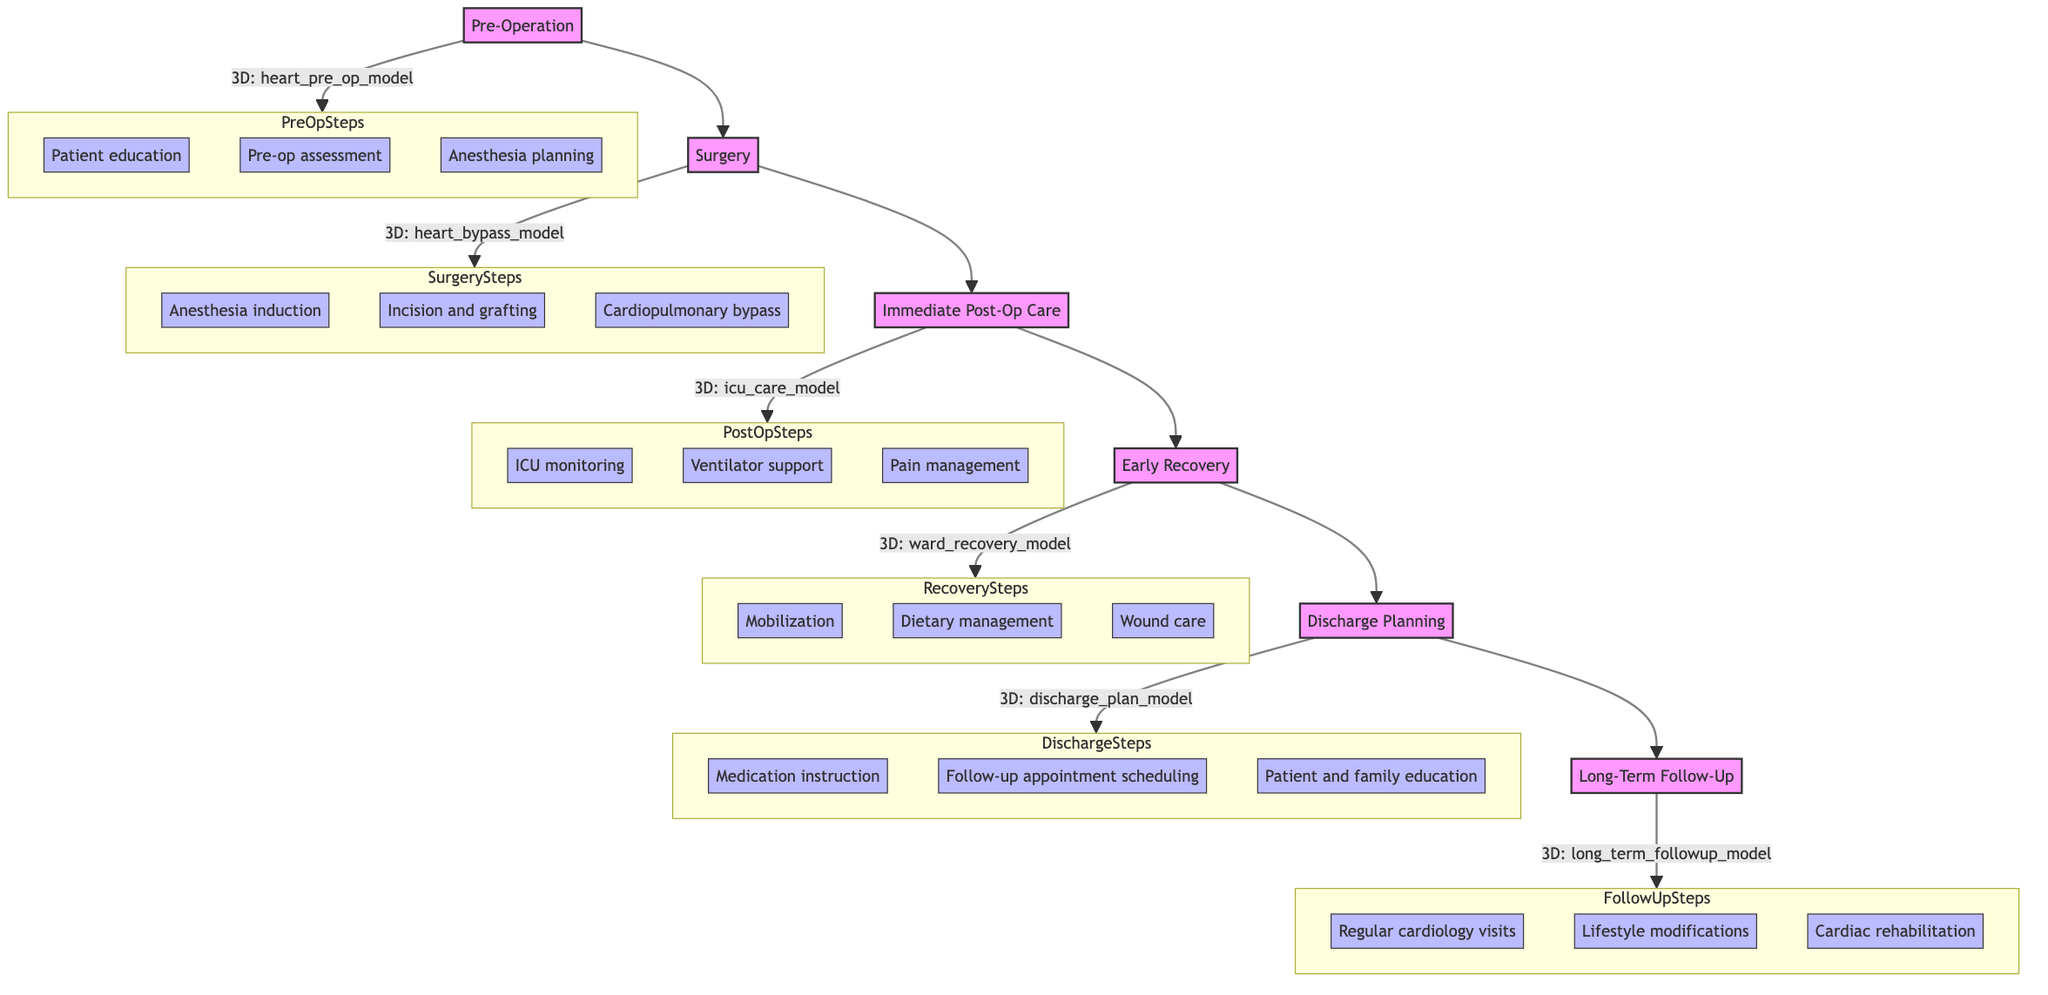What is the first stage in the clinical pathway? The first stage in the clinical pathway is identified at the beginning of the flow, which is labeled as "Pre-Operation."
Answer: Pre-Operation How many stages are in the clinical pathway? By counting the stages listed in the diagram, there are a total of six stages: Pre-Operation, Surgery, Immediate Post-Op Care, Early Recovery, Discharge Planning, and Long-Term Follow-Up.
Answer: 6 What is the 3D visualization for the Immediate Post-Op Care stage? Each stage includes a specific 3D visualization mentioned beside it; for Immediate Post-Op Care, the visualization is "icu_care_model."
Answer: icu_care_model Which stage directly follows Surgery? In the flow of the clinical pathway, the stage that comes immediately after Surgery is Immediate Post-Op Care.
Answer: Immediate Post-Op Care What are the key steps involved in the Early Recovery stage? In the Early Recovery stage, the key steps listed are Mobilization, Dietary management, and Wound care.
Answer: Mobilization, Dietary management, Wound care What is the last stage in the clinical pathway? The last stage in the clinical pathway is at the end of the flow and is labeled as "Long-Term Follow-Up."
Answer: Long-Term Follow-Up How many key steps are there in the Discharge Planning stage? By examining the steps listed under Discharge Planning, we see there are three key steps: Medication instruction, Follow-up appointment scheduling, and Patient and family education.
Answer: 3 What is the guideline for the Surgery stage? Each stage has specific guidelines; for the Surgery stage, one of the guidelines is "Monitor vital signs."
Answer: Monitor vital signs Which guideline relates to infection prevention? The guideline relating to infection prevention is found in the Immediate Post-Op Care stage, specifically stating "Infection prevention."
Answer: Infection prevention 